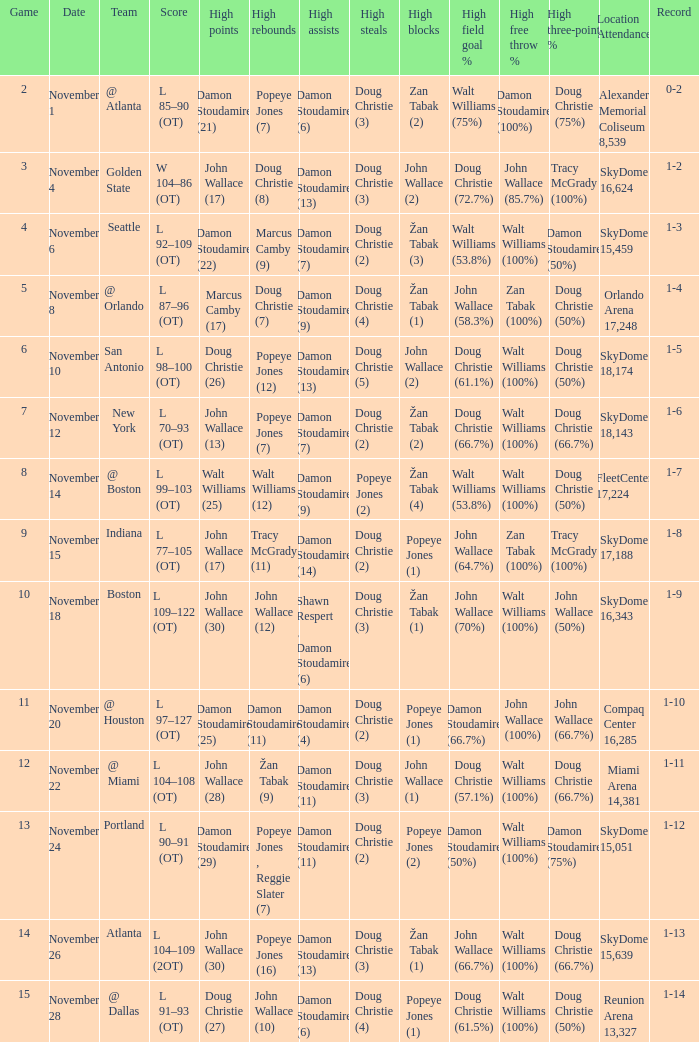How many games did the team play when they were 1-3? 1.0. 